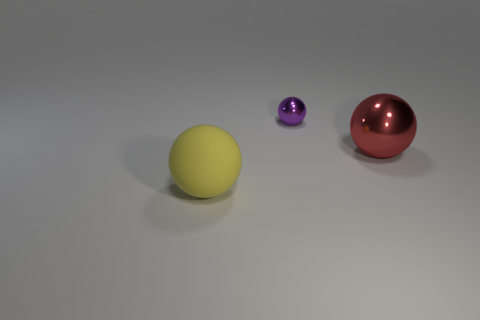Add 1 shiny objects. How many objects exist? 4 Add 2 large red balls. How many large red balls are left? 3 Add 1 small blue shiny blocks. How many small blue shiny blocks exist? 1 Subtract 0 gray cylinders. How many objects are left? 3 Subtract all rubber spheres. Subtract all rubber objects. How many objects are left? 1 